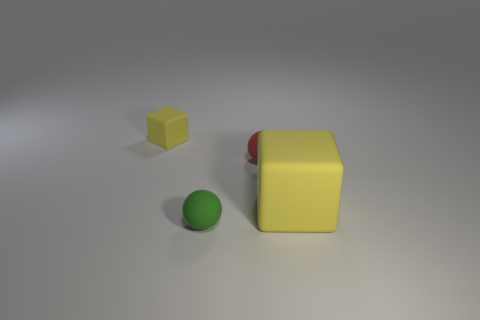What number of other large cubes have the same color as the large block?
Your answer should be compact. 0. What number of other tiny spheres have the same material as the small red ball?
Provide a short and direct response. 1. Is the number of yellow blocks behind the large yellow object greater than the number of tiny cyan cylinders?
Offer a terse response. Yes. What size is the other block that is the same color as the tiny matte block?
Make the answer very short. Large. Is there a tiny red object of the same shape as the large thing?
Give a very brief answer. No. What number of things are either big gray blocks or big rubber objects?
Provide a short and direct response. 1. There is a cube left of the yellow block that is on the right side of the green rubber object; what number of small rubber balls are right of it?
Give a very brief answer. 2. What is the object that is both behind the large thing and on the left side of the red ball made of?
Keep it short and to the point. Rubber. Is the number of yellow cubes behind the tiny rubber cube less than the number of green balls that are in front of the large yellow cube?
Keep it short and to the point. Yes. There is a thing to the right of the tiny rubber ball right of the rubber ball that is in front of the large yellow matte thing; what is its shape?
Ensure brevity in your answer.  Cube. 